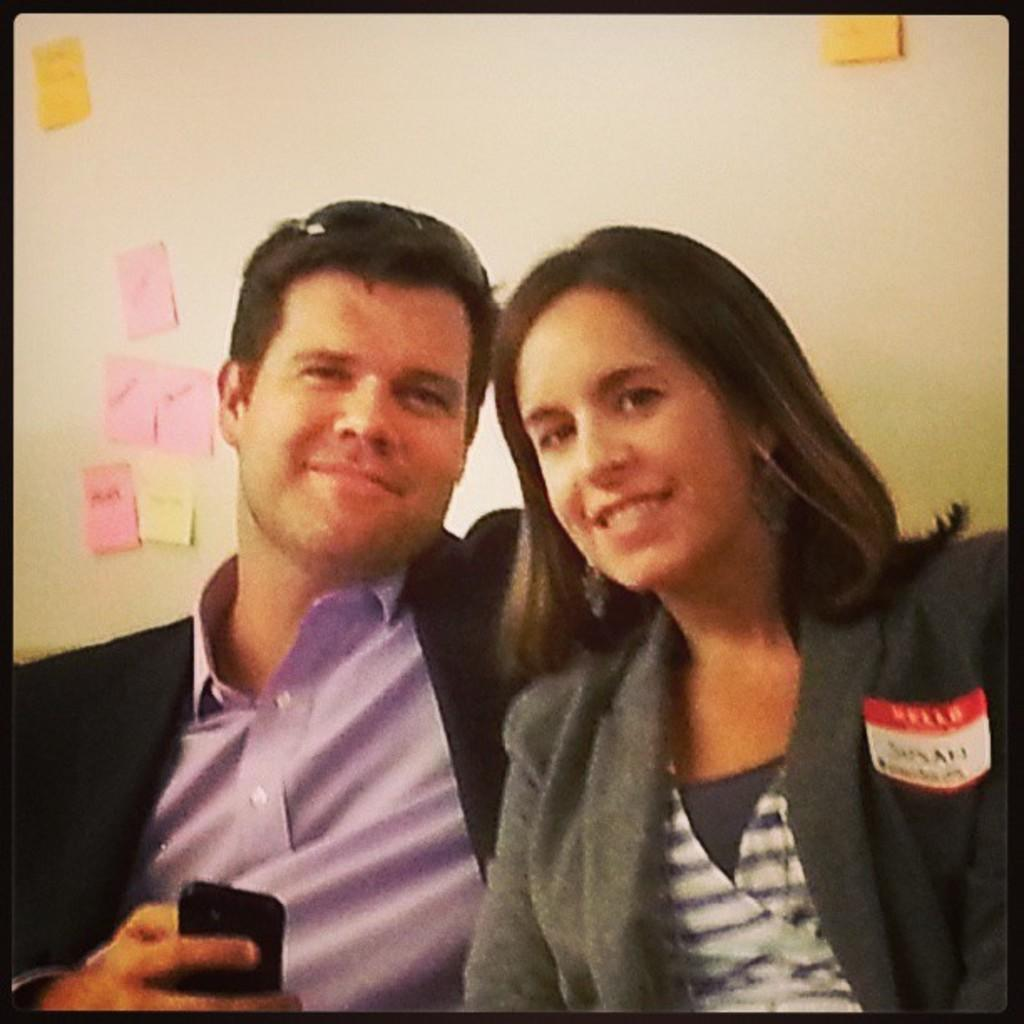How many people are present in the image? There are two people in the image. What is one of the people doing in the image? One of the people is holding an object. What can be seen on the wall in the background of the image? There are sticky notes on a wall in the background. Can you see a kitten playing in the rain in the image? There is no kitten or rain present in the image. Is there a cook preparing a meal in the image? There is no cook or meal preparation depicted in the image. 